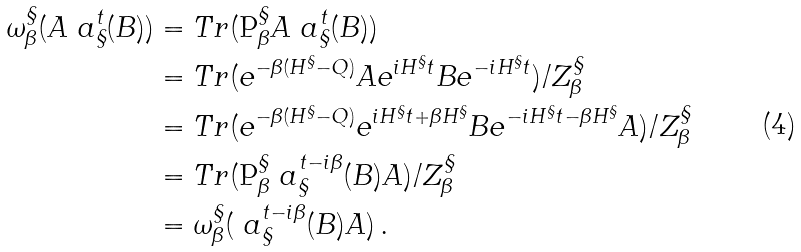<formula> <loc_0><loc_0><loc_500><loc_500>\omega ^ { \S } _ { \beta } ( A \ a _ { \S } ^ { t } ( B ) ) & = T r ( { \mathsf P } ^ { \S } _ { \beta } A \ a _ { \S } ^ { t } ( B ) ) \\ & = T r ( e ^ { - \beta ( H ^ { \S } - Q ) } A e ^ { i H ^ { \S } t } B e ^ { - i H ^ { \S } t } ) / Z ^ { \S } _ { \beta } \\ & = T r ( e ^ { - \beta ( H ^ { \S } - Q ) } e ^ { i H ^ { \S } t + \beta H ^ { \S } } B e ^ { - i H ^ { \S } t - \beta H ^ { \S } } A ) / Z ^ { \S } _ { \beta } \\ & = T r ( { \mathsf P } ^ { \S } _ { \beta } \ a _ { \S } ^ { t - i \beta } ( B ) A ) / Z ^ { \S } _ { \beta } \\ & = \omega ^ { \S } _ { \beta } ( \ a _ { \S } ^ { t - i \beta } ( B ) A ) \, .</formula> 